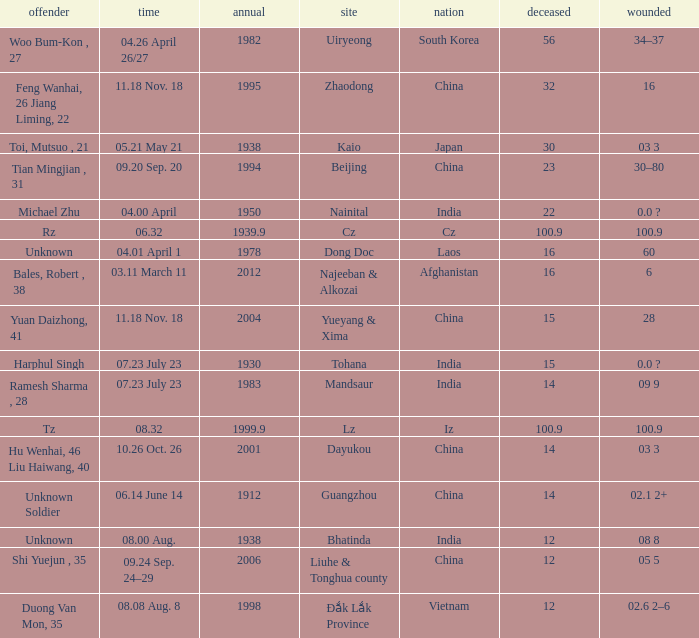What is Injured, when Country is "Afghanistan"? 6.0. 